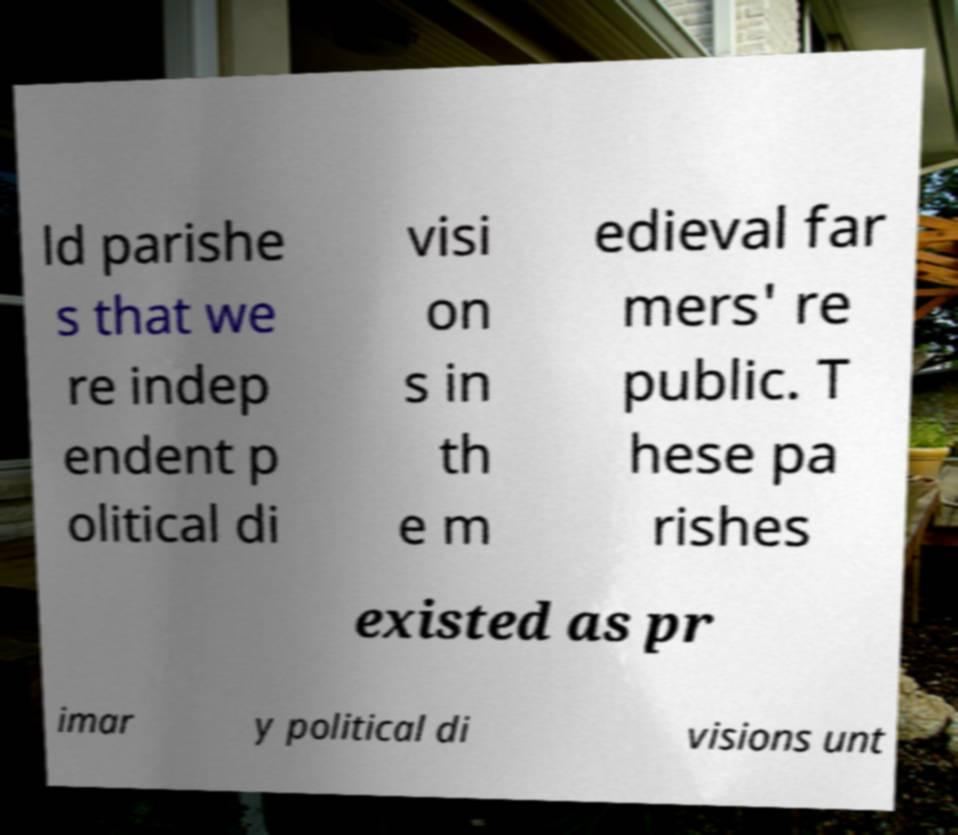Could you extract and type out the text from this image? ld parishe s that we re indep endent p olitical di visi on s in th e m edieval far mers' re public. T hese pa rishes existed as pr imar y political di visions unt 